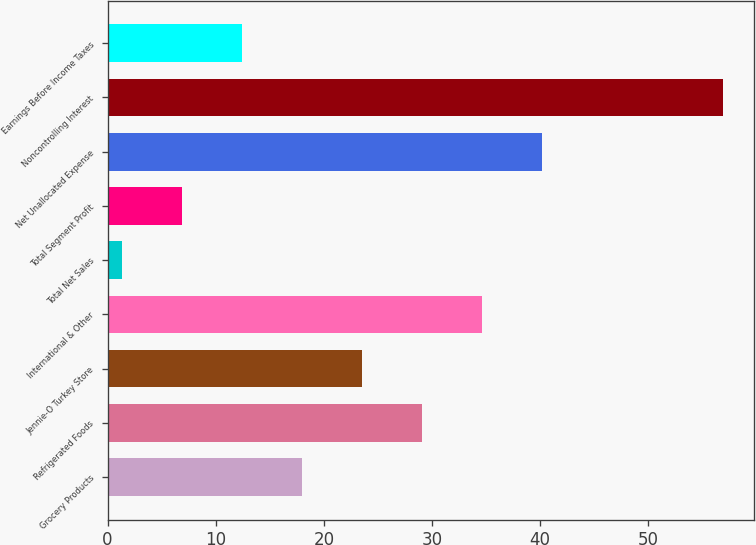Convert chart to OTSL. <chart><loc_0><loc_0><loc_500><loc_500><bar_chart><fcel>Grocery Products<fcel>Refrigerated Foods<fcel>Jennie-O Turkey Store<fcel>International & Other<fcel>Total Net Sales<fcel>Total Segment Profit<fcel>Net Unallocated Expense<fcel>Noncontrolling Interest<fcel>Earnings Before Income Taxes<nl><fcel>17.98<fcel>29.1<fcel>23.54<fcel>34.66<fcel>1.3<fcel>6.86<fcel>40.22<fcel>56.9<fcel>12.42<nl></chart> 